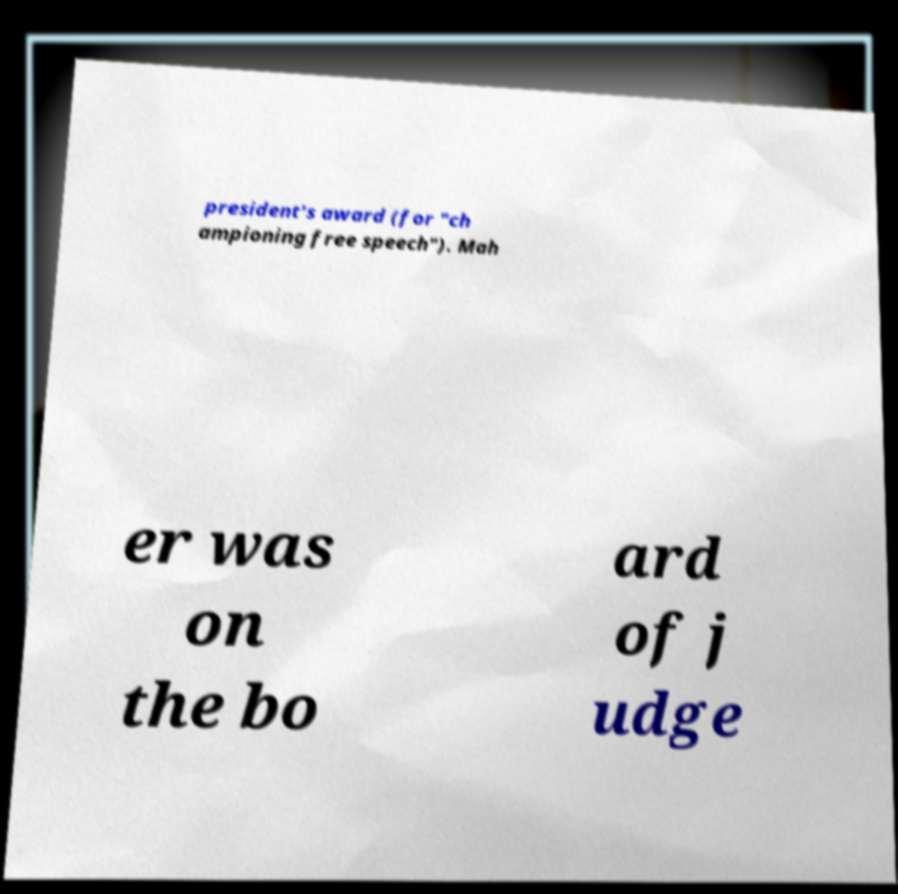Please read and relay the text visible in this image. What does it say? president's award (for "ch ampioning free speech"). Mah er was on the bo ard of j udge 